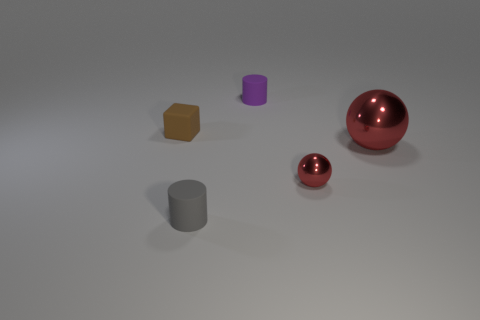How many other objects are the same shape as the large thing?
Offer a terse response. 1. The other shiny thing that is the same size as the purple object is what color?
Offer a terse response. Red. Are there an equal number of tiny red spheres on the right side of the small ball and red metal things?
Offer a terse response. No. The tiny thing that is both in front of the large metallic ball and left of the small red object has what shape?
Offer a very short reply. Cylinder. Do the block and the gray matte cylinder have the same size?
Make the answer very short. Yes. Are there any tiny gray things that have the same material as the tiny block?
Offer a very short reply. Yes. What size is the object that is the same color as the tiny metal ball?
Keep it short and to the point. Large. How many things are both left of the big red sphere and to the right of the tiny purple cylinder?
Provide a short and direct response. 1. There is a tiny cylinder that is in front of the small brown matte cube; what material is it?
Offer a terse response. Rubber. What number of balls have the same color as the cube?
Give a very brief answer. 0. 